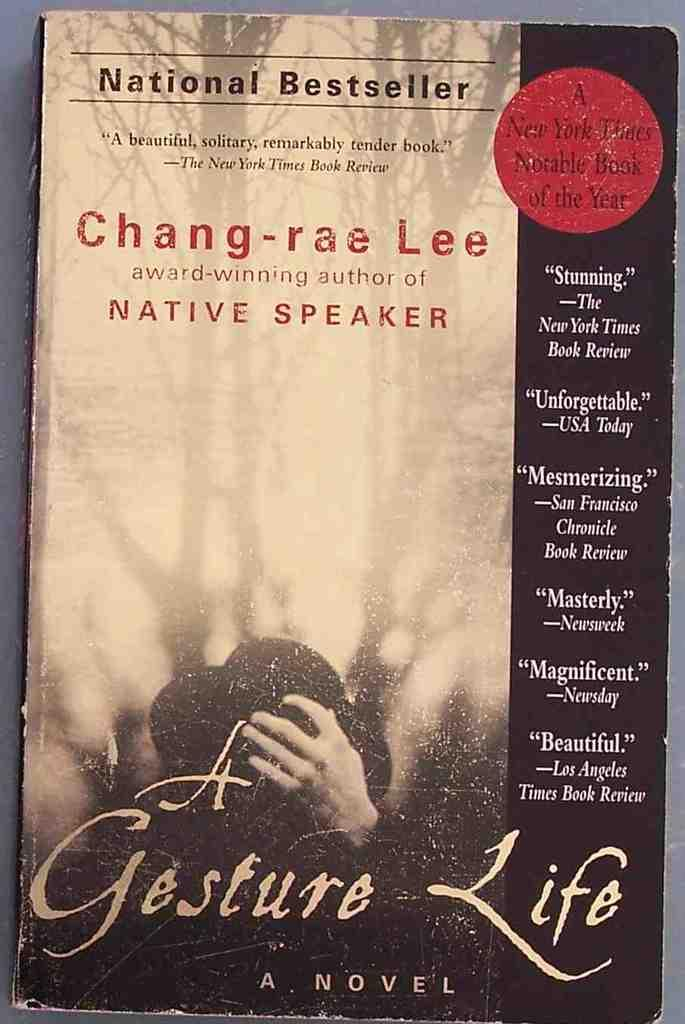<image>
Give a short and clear explanation of the subsequent image. A national best seller and a beautifully written book. 